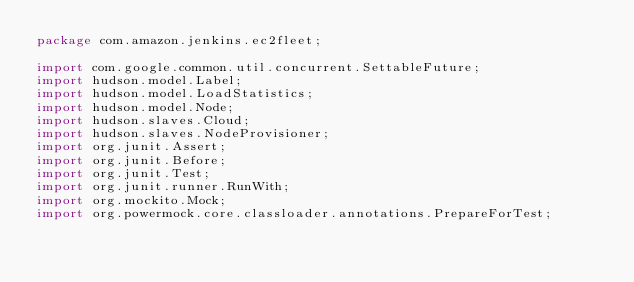<code> <loc_0><loc_0><loc_500><loc_500><_Java_>package com.amazon.jenkins.ec2fleet;

import com.google.common.util.concurrent.SettableFuture;
import hudson.model.Label;
import hudson.model.LoadStatistics;
import hudson.model.Node;
import hudson.slaves.Cloud;
import hudson.slaves.NodeProvisioner;
import org.junit.Assert;
import org.junit.Before;
import org.junit.Test;
import org.junit.runner.RunWith;
import org.mockito.Mock;
import org.powermock.core.classloader.annotations.PrepareForTest;</code> 